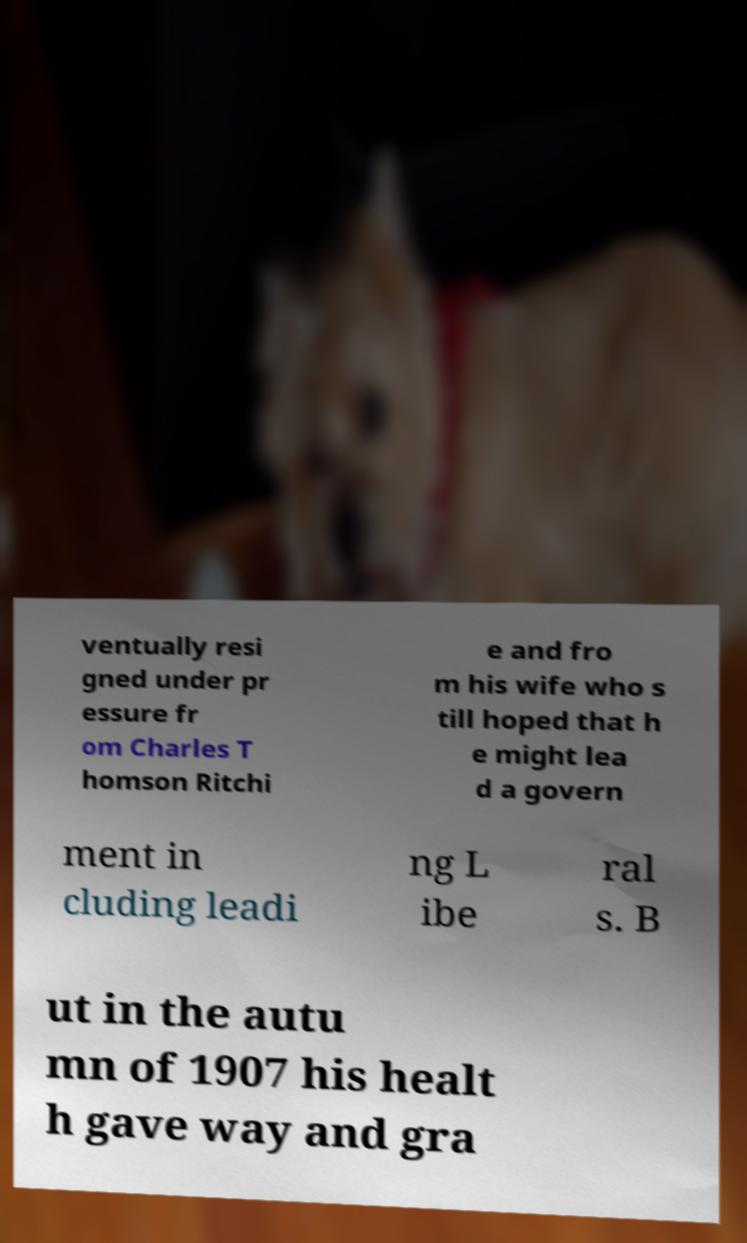Please read and relay the text visible in this image. What does it say? ventually resi gned under pr essure fr om Charles T homson Ritchi e and fro m his wife who s till hoped that h e might lea d a govern ment in cluding leadi ng L ibe ral s. B ut in the autu mn of 1907 his healt h gave way and gra 